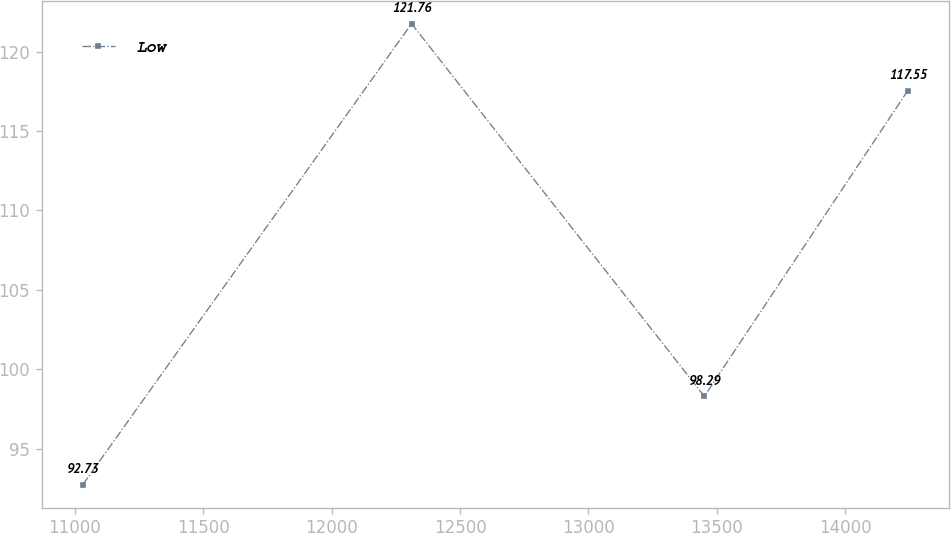<chart> <loc_0><loc_0><loc_500><loc_500><line_chart><ecel><fcel>Low<nl><fcel>11030.6<fcel>92.73<nl><fcel>12310.9<fcel>121.76<nl><fcel>13451.2<fcel>98.29<nl><fcel>14243.8<fcel>117.55<nl></chart> 